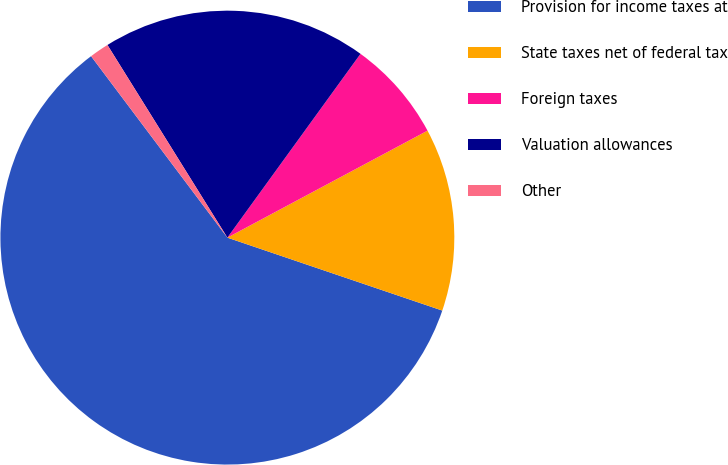Convert chart to OTSL. <chart><loc_0><loc_0><loc_500><loc_500><pie_chart><fcel>Provision for income taxes at<fcel>State taxes net of federal tax<fcel>Foreign taxes<fcel>Valuation allowances<fcel>Other<nl><fcel>59.54%<fcel>13.02%<fcel>7.21%<fcel>18.84%<fcel>1.39%<nl></chart> 